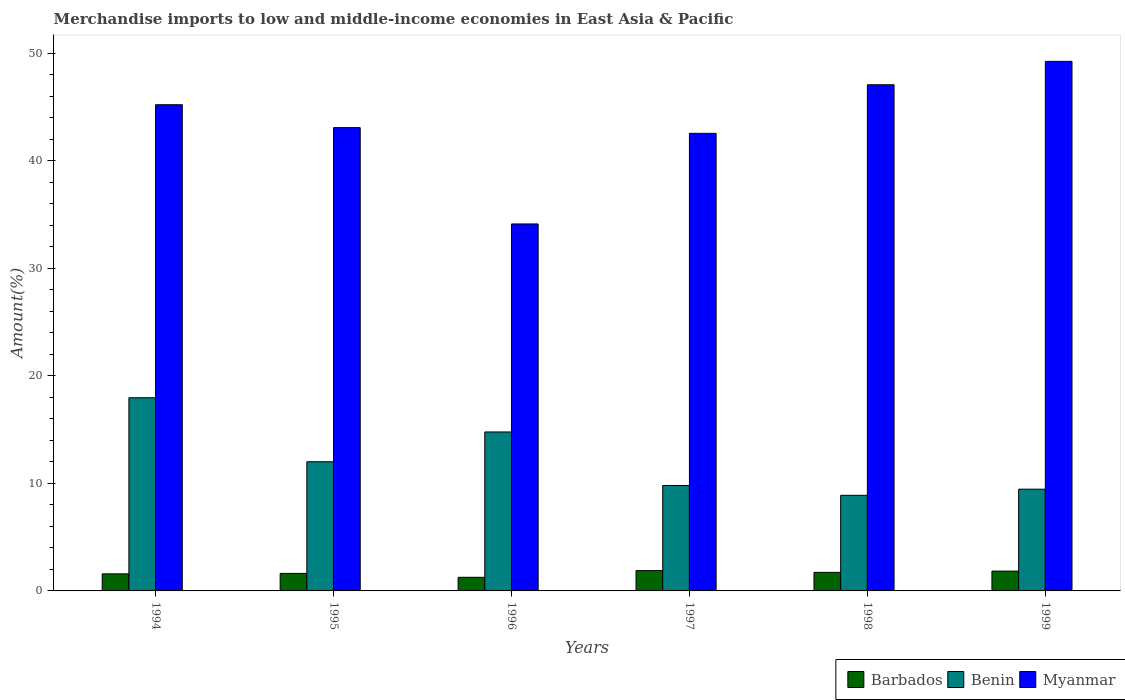How many different coloured bars are there?
Give a very brief answer. 3. Are the number of bars per tick equal to the number of legend labels?
Give a very brief answer. Yes. Are the number of bars on each tick of the X-axis equal?
Give a very brief answer. Yes. How many bars are there on the 4th tick from the left?
Provide a succinct answer. 3. How many bars are there on the 2nd tick from the right?
Offer a terse response. 3. What is the label of the 1st group of bars from the left?
Offer a very short reply. 1994. What is the percentage of amount earned from merchandise imports in Myanmar in 1999?
Your answer should be very brief. 49.23. Across all years, what is the maximum percentage of amount earned from merchandise imports in Myanmar?
Your response must be concise. 49.23. Across all years, what is the minimum percentage of amount earned from merchandise imports in Barbados?
Make the answer very short. 1.27. In which year was the percentage of amount earned from merchandise imports in Benin maximum?
Provide a succinct answer. 1994. In which year was the percentage of amount earned from merchandise imports in Myanmar minimum?
Your answer should be very brief. 1996. What is the total percentage of amount earned from merchandise imports in Myanmar in the graph?
Give a very brief answer. 261.21. What is the difference between the percentage of amount earned from merchandise imports in Barbados in 1996 and that in 1997?
Offer a terse response. -0.63. What is the difference between the percentage of amount earned from merchandise imports in Myanmar in 1998 and the percentage of amount earned from merchandise imports in Benin in 1994?
Provide a short and direct response. 29.1. What is the average percentage of amount earned from merchandise imports in Benin per year?
Your answer should be very brief. 12.15. In the year 1997, what is the difference between the percentage of amount earned from merchandise imports in Barbados and percentage of amount earned from merchandise imports in Benin?
Offer a terse response. -7.91. In how many years, is the percentage of amount earned from merchandise imports in Benin greater than 20 %?
Your answer should be very brief. 0. What is the ratio of the percentage of amount earned from merchandise imports in Benin in 1994 to that in 1996?
Offer a terse response. 1.22. Is the percentage of amount earned from merchandise imports in Myanmar in 1995 less than that in 1998?
Ensure brevity in your answer.  Yes. Is the difference between the percentage of amount earned from merchandise imports in Barbados in 1994 and 1995 greater than the difference between the percentage of amount earned from merchandise imports in Benin in 1994 and 1995?
Your response must be concise. No. What is the difference between the highest and the second highest percentage of amount earned from merchandise imports in Benin?
Make the answer very short. 3.18. What is the difference between the highest and the lowest percentage of amount earned from merchandise imports in Barbados?
Make the answer very short. 0.63. What does the 1st bar from the left in 1997 represents?
Provide a succinct answer. Barbados. What does the 2nd bar from the right in 1995 represents?
Ensure brevity in your answer.  Benin. Are all the bars in the graph horizontal?
Your answer should be very brief. No. How many years are there in the graph?
Your response must be concise. 6. Are the values on the major ticks of Y-axis written in scientific E-notation?
Ensure brevity in your answer.  No. Does the graph contain grids?
Ensure brevity in your answer.  No. How are the legend labels stacked?
Provide a short and direct response. Horizontal. What is the title of the graph?
Keep it short and to the point. Merchandise imports to low and middle-income economies in East Asia & Pacific. Does "Brazil" appear as one of the legend labels in the graph?
Offer a terse response. No. What is the label or title of the Y-axis?
Offer a very short reply. Amount(%). What is the Amount(%) in Barbados in 1994?
Your answer should be very brief. 1.58. What is the Amount(%) in Benin in 1994?
Offer a terse response. 17.96. What is the Amount(%) of Myanmar in 1994?
Give a very brief answer. 45.2. What is the Amount(%) in Barbados in 1995?
Your response must be concise. 1.63. What is the Amount(%) in Benin in 1995?
Offer a terse response. 12.01. What is the Amount(%) of Myanmar in 1995?
Make the answer very short. 43.07. What is the Amount(%) of Barbados in 1996?
Keep it short and to the point. 1.27. What is the Amount(%) in Benin in 1996?
Your response must be concise. 14.78. What is the Amount(%) of Myanmar in 1996?
Your answer should be very brief. 34.12. What is the Amount(%) of Barbados in 1997?
Your response must be concise. 1.89. What is the Amount(%) in Benin in 1997?
Ensure brevity in your answer.  9.8. What is the Amount(%) of Myanmar in 1997?
Keep it short and to the point. 42.54. What is the Amount(%) of Barbados in 1998?
Offer a very short reply. 1.72. What is the Amount(%) in Benin in 1998?
Provide a short and direct response. 8.89. What is the Amount(%) of Myanmar in 1998?
Offer a very short reply. 47.05. What is the Amount(%) of Barbados in 1999?
Provide a succinct answer. 1.84. What is the Amount(%) of Benin in 1999?
Ensure brevity in your answer.  9.46. What is the Amount(%) of Myanmar in 1999?
Ensure brevity in your answer.  49.23. Across all years, what is the maximum Amount(%) of Barbados?
Make the answer very short. 1.89. Across all years, what is the maximum Amount(%) in Benin?
Your answer should be compact. 17.96. Across all years, what is the maximum Amount(%) in Myanmar?
Give a very brief answer. 49.23. Across all years, what is the minimum Amount(%) of Barbados?
Your response must be concise. 1.27. Across all years, what is the minimum Amount(%) in Benin?
Offer a terse response. 8.89. Across all years, what is the minimum Amount(%) of Myanmar?
Ensure brevity in your answer.  34.12. What is the total Amount(%) of Barbados in the graph?
Your answer should be compact. 9.94. What is the total Amount(%) in Benin in the graph?
Ensure brevity in your answer.  72.89. What is the total Amount(%) of Myanmar in the graph?
Provide a succinct answer. 261.21. What is the difference between the Amount(%) in Barbados in 1994 and that in 1995?
Ensure brevity in your answer.  -0.04. What is the difference between the Amount(%) of Benin in 1994 and that in 1995?
Offer a terse response. 5.95. What is the difference between the Amount(%) of Myanmar in 1994 and that in 1995?
Your response must be concise. 2.13. What is the difference between the Amount(%) of Barbados in 1994 and that in 1996?
Keep it short and to the point. 0.32. What is the difference between the Amount(%) in Benin in 1994 and that in 1996?
Provide a short and direct response. 3.18. What is the difference between the Amount(%) of Myanmar in 1994 and that in 1996?
Offer a very short reply. 11.08. What is the difference between the Amount(%) in Barbados in 1994 and that in 1997?
Ensure brevity in your answer.  -0.31. What is the difference between the Amount(%) in Benin in 1994 and that in 1997?
Make the answer very short. 8.16. What is the difference between the Amount(%) in Myanmar in 1994 and that in 1997?
Provide a succinct answer. 2.66. What is the difference between the Amount(%) in Barbados in 1994 and that in 1998?
Your response must be concise. -0.14. What is the difference between the Amount(%) of Benin in 1994 and that in 1998?
Your answer should be compact. 9.07. What is the difference between the Amount(%) in Myanmar in 1994 and that in 1998?
Your answer should be very brief. -1.86. What is the difference between the Amount(%) in Barbados in 1994 and that in 1999?
Offer a terse response. -0.26. What is the difference between the Amount(%) of Benin in 1994 and that in 1999?
Give a very brief answer. 8.5. What is the difference between the Amount(%) of Myanmar in 1994 and that in 1999?
Your answer should be very brief. -4.03. What is the difference between the Amount(%) of Barbados in 1995 and that in 1996?
Offer a very short reply. 0.36. What is the difference between the Amount(%) of Benin in 1995 and that in 1996?
Your answer should be very brief. -2.77. What is the difference between the Amount(%) in Myanmar in 1995 and that in 1996?
Provide a short and direct response. 8.96. What is the difference between the Amount(%) in Barbados in 1995 and that in 1997?
Your answer should be very brief. -0.26. What is the difference between the Amount(%) in Benin in 1995 and that in 1997?
Offer a terse response. 2.21. What is the difference between the Amount(%) of Myanmar in 1995 and that in 1997?
Your answer should be compact. 0.53. What is the difference between the Amount(%) in Barbados in 1995 and that in 1998?
Ensure brevity in your answer.  -0.1. What is the difference between the Amount(%) of Benin in 1995 and that in 1998?
Your answer should be very brief. 3.12. What is the difference between the Amount(%) of Myanmar in 1995 and that in 1998?
Your response must be concise. -3.98. What is the difference between the Amount(%) in Barbados in 1995 and that in 1999?
Offer a terse response. -0.22. What is the difference between the Amount(%) in Benin in 1995 and that in 1999?
Make the answer very short. 2.55. What is the difference between the Amount(%) of Myanmar in 1995 and that in 1999?
Make the answer very short. -6.16. What is the difference between the Amount(%) of Barbados in 1996 and that in 1997?
Your answer should be very brief. -0.63. What is the difference between the Amount(%) in Benin in 1996 and that in 1997?
Give a very brief answer. 4.97. What is the difference between the Amount(%) in Myanmar in 1996 and that in 1997?
Your answer should be very brief. -8.42. What is the difference between the Amount(%) in Barbados in 1996 and that in 1998?
Make the answer very short. -0.46. What is the difference between the Amount(%) of Benin in 1996 and that in 1998?
Your answer should be compact. 5.89. What is the difference between the Amount(%) of Myanmar in 1996 and that in 1998?
Offer a terse response. -12.94. What is the difference between the Amount(%) of Barbados in 1996 and that in 1999?
Make the answer very short. -0.58. What is the difference between the Amount(%) in Benin in 1996 and that in 1999?
Your answer should be compact. 5.32. What is the difference between the Amount(%) of Myanmar in 1996 and that in 1999?
Give a very brief answer. -15.11. What is the difference between the Amount(%) in Barbados in 1997 and that in 1998?
Offer a very short reply. 0.17. What is the difference between the Amount(%) in Benin in 1997 and that in 1998?
Offer a very short reply. 0.91. What is the difference between the Amount(%) of Myanmar in 1997 and that in 1998?
Your answer should be very brief. -4.51. What is the difference between the Amount(%) in Barbados in 1997 and that in 1999?
Make the answer very short. 0.05. What is the difference between the Amount(%) of Benin in 1997 and that in 1999?
Provide a succinct answer. 0.34. What is the difference between the Amount(%) of Myanmar in 1997 and that in 1999?
Ensure brevity in your answer.  -6.69. What is the difference between the Amount(%) of Barbados in 1998 and that in 1999?
Your answer should be very brief. -0.12. What is the difference between the Amount(%) of Benin in 1998 and that in 1999?
Offer a very short reply. -0.57. What is the difference between the Amount(%) in Myanmar in 1998 and that in 1999?
Offer a terse response. -2.18. What is the difference between the Amount(%) in Barbados in 1994 and the Amount(%) in Benin in 1995?
Give a very brief answer. -10.42. What is the difference between the Amount(%) in Barbados in 1994 and the Amount(%) in Myanmar in 1995?
Keep it short and to the point. -41.49. What is the difference between the Amount(%) in Benin in 1994 and the Amount(%) in Myanmar in 1995?
Your answer should be compact. -25.11. What is the difference between the Amount(%) in Barbados in 1994 and the Amount(%) in Benin in 1996?
Ensure brevity in your answer.  -13.19. What is the difference between the Amount(%) of Barbados in 1994 and the Amount(%) of Myanmar in 1996?
Provide a succinct answer. -32.53. What is the difference between the Amount(%) of Benin in 1994 and the Amount(%) of Myanmar in 1996?
Keep it short and to the point. -16.16. What is the difference between the Amount(%) in Barbados in 1994 and the Amount(%) in Benin in 1997?
Offer a terse response. -8.22. What is the difference between the Amount(%) of Barbados in 1994 and the Amount(%) of Myanmar in 1997?
Give a very brief answer. -40.95. What is the difference between the Amount(%) in Benin in 1994 and the Amount(%) in Myanmar in 1997?
Offer a very short reply. -24.58. What is the difference between the Amount(%) of Barbados in 1994 and the Amount(%) of Benin in 1998?
Give a very brief answer. -7.3. What is the difference between the Amount(%) of Barbados in 1994 and the Amount(%) of Myanmar in 1998?
Offer a very short reply. -45.47. What is the difference between the Amount(%) of Benin in 1994 and the Amount(%) of Myanmar in 1998?
Keep it short and to the point. -29.1. What is the difference between the Amount(%) of Barbados in 1994 and the Amount(%) of Benin in 1999?
Ensure brevity in your answer.  -7.87. What is the difference between the Amount(%) in Barbados in 1994 and the Amount(%) in Myanmar in 1999?
Keep it short and to the point. -47.65. What is the difference between the Amount(%) of Benin in 1994 and the Amount(%) of Myanmar in 1999?
Ensure brevity in your answer.  -31.27. What is the difference between the Amount(%) in Barbados in 1995 and the Amount(%) in Benin in 1996?
Provide a short and direct response. -13.15. What is the difference between the Amount(%) in Barbados in 1995 and the Amount(%) in Myanmar in 1996?
Keep it short and to the point. -32.49. What is the difference between the Amount(%) of Benin in 1995 and the Amount(%) of Myanmar in 1996?
Make the answer very short. -22.11. What is the difference between the Amount(%) of Barbados in 1995 and the Amount(%) of Benin in 1997?
Offer a terse response. -8.17. What is the difference between the Amount(%) in Barbados in 1995 and the Amount(%) in Myanmar in 1997?
Give a very brief answer. -40.91. What is the difference between the Amount(%) of Benin in 1995 and the Amount(%) of Myanmar in 1997?
Provide a succinct answer. -30.53. What is the difference between the Amount(%) in Barbados in 1995 and the Amount(%) in Benin in 1998?
Your response must be concise. -7.26. What is the difference between the Amount(%) in Barbados in 1995 and the Amount(%) in Myanmar in 1998?
Your answer should be compact. -45.43. What is the difference between the Amount(%) in Benin in 1995 and the Amount(%) in Myanmar in 1998?
Your answer should be very brief. -35.04. What is the difference between the Amount(%) of Barbados in 1995 and the Amount(%) of Benin in 1999?
Offer a very short reply. -7.83. What is the difference between the Amount(%) in Barbados in 1995 and the Amount(%) in Myanmar in 1999?
Offer a terse response. -47.6. What is the difference between the Amount(%) of Benin in 1995 and the Amount(%) of Myanmar in 1999?
Your answer should be very brief. -37.22. What is the difference between the Amount(%) in Barbados in 1996 and the Amount(%) in Benin in 1997?
Provide a succinct answer. -8.54. What is the difference between the Amount(%) of Barbados in 1996 and the Amount(%) of Myanmar in 1997?
Provide a short and direct response. -41.27. What is the difference between the Amount(%) in Benin in 1996 and the Amount(%) in Myanmar in 1997?
Provide a succinct answer. -27.76. What is the difference between the Amount(%) in Barbados in 1996 and the Amount(%) in Benin in 1998?
Provide a succinct answer. -7.62. What is the difference between the Amount(%) in Barbados in 1996 and the Amount(%) in Myanmar in 1998?
Keep it short and to the point. -45.79. What is the difference between the Amount(%) of Benin in 1996 and the Amount(%) of Myanmar in 1998?
Provide a succinct answer. -32.28. What is the difference between the Amount(%) in Barbados in 1996 and the Amount(%) in Benin in 1999?
Keep it short and to the point. -8.19. What is the difference between the Amount(%) of Barbados in 1996 and the Amount(%) of Myanmar in 1999?
Offer a very short reply. -47.96. What is the difference between the Amount(%) in Benin in 1996 and the Amount(%) in Myanmar in 1999?
Offer a very short reply. -34.45. What is the difference between the Amount(%) of Barbados in 1997 and the Amount(%) of Benin in 1998?
Give a very brief answer. -7. What is the difference between the Amount(%) in Barbados in 1997 and the Amount(%) in Myanmar in 1998?
Offer a terse response. -45.16. What is the difference between the Amount(%) of Benin in 1997 and the Amount(%) of Myanmar in 1998?
Provide a succinct answer. -37.25. What is the difference between the Amount(%) of Barbados in 1997 and the Amount(%) of Benin in 1999?
Ensure brevity in your answer.  -7.57. What is the difference between the Amount(%) in Barbados in 1997 and the Amount(%) in Myanmar in 1999?
Ensure brevity in your answer.  -47.34. What is the difference between the Amount(%) in Benin in 1997 and the Amount(%) in Myanmar in 1999?
Ensure brevity in your answer.  -39.43. What is the difference between the Amount(%) in Barbados in 1998 and the Amount(%) in Benin in 1999?
Ensure brevity in your answer.  -7.73. What is the difference between the Amount(%) in Barbados in 1998 and the Amount(%) in Myanmar in 1999?
Your response must be concise. -47.51. What is the difference between the Amount(%) of Benin in 1998 and the Amount(%) of Myanmar in 1999?
Provide a succinct answer. -40.34. What is the average Amount(%) of Barbados per year?
Give a very brief answer. 1.66. What is the average Amount(%) in Benin per year?
Offer a terse response. 12.15. What is the average Amount(%) of Myanmar per year?
Provide a short and direct response. 43.53. In the year 1994, what is the difference between the Amount(%) in Barbados and Amount(%) in Benin?
Keep it short and to the point. -16.37. In the year 1994, what is the difference between the Amount(%) of Barbados and Amount(%) of Myanmar?
Make the answer very short. -43.61. In the year 1994, what is the difference between the Amount(%) of Benin and Amount(%) of Myanmar?
Your answer should be very brief. -27.24. In the year 1995, what is the difference between the Amount(%) in Barbados and Amount(%) in Benin?
Your answer should be compact. -10.38. In the year 1995, what is the difference between the Amount(%) in Barbados and Amount(%) in Myanmar?
Provide a short and direct response. -41.44. In the year 1995, what is the difference between the Amount(%) in Benin and Amount(%) in Myanmar?
Provide a short and direct response. -31.06. In the year 1996, what is the difference between the Amount(%) in Barbados and Amount(%) in Benin?
Give a very brief answer. -13.51. In the year 1996, what is the difference between the Amount(%) in Barbados and Amount(%) in Myanmar?
Your response must be concise. -32.85. In the year 1996, what is the difference between the Amount(%) of Benin and Amount(%) of Myanmar?
Make the answer very short. -19.34. In the year 1997, what is the difference between the Amount(%) of Barbados and Amount(%) of Benin?
Your response must be concise. -7.91. In the year 1997, what is the difference between the Amount(%) in Barbados and Amount(%) in Myanmar?
Your answer should be very brief. -40.65. In the year 1997, what is the difference between the Amount(%) in Benin and Amount(%) in Myanmar?
Your answer should be compact. -32.74. In the year 1998, what is the difference between the Amount(%) of Barbados and Amount(%) of Benin?
Your answer should be compact. -7.16. In the year 1998, what is the difference between the Amount(%) of Barbados and Amount(%) of Myanmar?
Give a very brief answer. -45.33. In the year 1998, what is the difference between the Amount(%) in Benin and Amount(%) in Myanmar?
Give a very brief answer. -38.17. In the year 1999, what is the difference between the Amount(%) of Barbados and Amount(%) of Benin?
Provide a short and direct response. -7.61. In the year 1999, what is the difference between the Amount(%) in Barbados and Amount(%) in Myanmar?
Offer a terse response. -47.39. In the year 1999, what is the difference between the Amount(%) in Benin and Amount(%) in Myanmar?
Provide a succinct answer. -39.77. What is the ratio of the Amount(%) of Barbados in 1994 to that in 1995?
Keep it short and to the point. 0.97. What is the ratio of the Amount(%) in Benin in 1994 to that in 1995?
Keep it short and to the point. 1.5. What is the ratio of the Amount(%) of Myanmar in 1994 to that in 1995?
Your answer should be compact. 1.05. What is the ratio of the Amount(%) in Barbados in 1994 to that in 1996?
Give a very brief answer. 1.25. What is the ratio of the Amount(%) in Benin in 1994 to that in 1996?
Your answer should be very brief. 1.22. What is the ratio of the Amount(%) in Myanmar in 1994 to that in 1996?
Offer a very short reply. 1.32. What is the ratio of the Amount(%) of Barbados in 1994 to that in 1997?
Give a very brief answer. 0.84. What is the ratio of the Amount(%) in Benin in 1994 to that in 1997?
Offer a very short reply. 1.83. What is the ratio of the Amount(%) of Barbados in 1994 to that in 1998?
Make the answer very short. 0.92. What is the ratio of the Amount(%) of Benin in 1994 to that in 1998?
Provide a short and direct response. 2.02. What is the ratio of the Amount(%) of Myanmar in 1994 to that in 1998?
Your response must be concise. 0.96. What is the ratio of the Amount(%) of Barbados in 1994 to that in 1999?
Give a very brief answer. 0.86. What is the ratio of the Amount(%) of Benin in 1994 to that in 1999?
Offer a terse response. 1.9. What is the ratio of the Amount(%) in Myanmar in 1994 to that in 1999?
Your response must be concise. 0.92. What is the ratio of the Amount(%) in Barbados in 1995 to that in 1996?
Your answer should be very brief. 1.29. What is the ratio of the Amount(%) of Benin in 1995 to that in 1996?
Your answer should be very brief. 0.81. What is the ratio of the Amount(%) of Myanmar in 1995 to that in 1996?
Provide a succinct answer. 1.26. What is the ratio of the Amount(%) in Barbados in 1995 to that in 1997?
Your answer should be very brief. 0.86. What is the ratio of the Amount(%) in Benin in 1995 to that in 1997?
Your answer should be very brief. 1.23. What is the ratio of the Amount(%) of Myanmar in 1995 to that in 1997?
Offer a very short reply. 1.01. What is the ratio of the Amount(%) in Barbados in 1995 to that in 1998?
Offer a terse response. 0.94. What is the ratio of the Amount(%) in Benin in 1995 to that in 1998?
Provide a short and direct response. 1.35. What is the ratio of the Amount(%) in Myanmar in 1995 to that in 1998?
Ensure brevity in your answer.  0.92. What is the ratio of the Amount(%) in Barbados in 1995 to that in 1999?
Your response must be concise. 0.88. What is the ratio of the Amount(%) in Benin in 1995 to that in 1999?
Your answer should be compact. 1.27. What is the ratio of the Amount(%) of Myanmar in 1995 to that in 1999?
Your answer should be compact. 0.87. What is the ratio of the Amount(%) in Barbados in 1996 to that in 1997?
Provide a succinct answer. 0.67. What is the ratio of the Amount(%) of Benin in 1996 to that in 1997?
Your answer should be very brief. 1.51. What is the ratio of the Amount(%) in Myanmar in 1996 to that in 1997?
Ensure brevity in your answer.  0.8. What is the ratio of the Amount(%) of Barbados in 1996 to that in 1998?
Offer a very short reply. 0.73. What is the ratio of the Amount(%) of Benin in 1996 to that in 1998?
Keep it short and to the point. 1.66. What is the ratio of the Amount(%) of Myanmar in 1996 to that in 1998?
Your response must be concise. 0.72. What is the ratio of the Amount(%) of Barbados in 1996 to that in 1999?
Your response must be concise. 0.69. What is the ratio of the Amount(%) in Benin in 1996 to that in 1999?
Keep it short and to the point. 1.56. What is the ratio of the Amount(%) of Myanmar in 1996 to that in 1999?
Provide a succinct answer. 0.69. What is the ratio of the Amount(%) of Barbados in 1997 to that in 1998?
Offer a very short reply. 1.1. What is the ratio of the Amount(%) of Benin in 1997 to that in 1998?
Keep it short and to the point. 1.1. What is the ratio of the Amount(%) in Myanmar in 1997 to that in 1998?
Offer a very short reply. 0.9. What is the ratio of the Amount(%) of Barbados in 1997 to that in 1999?
Your answer should be compact. 1.03. What is the ratio of the Amount(%) in Benin in 1997 to that in 1999?
Ensure brevity in your answer.  1.04. What is the ratio of the Amount(%) of Myanmar in 1997 to that in 1999?
Provide a succinct answer. 0.86. What is the ratio of the Amount(%) in Barbados in 1998 to that in 1999?
Give a very brief answer. 0.93. What is the ratio of the Amount(%) in Benin in 1998 to that in 1999?
Provide a succinct answer. 0.94. What is the ratio of the Amount(%) in Myanmar in 1998 to that in 1999?
Keep it short and to the point. 0.96. What is the difference between the highest and the second highest Amount(%) in Barbados?
Provide a succinct answer. 0.05. What is the difference between the highest and the second highest Amount(%) of Benin?
Your response must be concise. 3.18. What is the difference between the highest and the second highest Amount(%) of Myanmar?
Offer a terse response. 2.18. What is the difference between the highest and the lowest Amount(%) in Barbados?
Offer a terse response. 0.63. What is the difference between the highest and the lowest Amount(%) of Benin?
Your answer should be compact. 9.07. What is the difference between the highest and the lowest Amount(%) of Myanmar?
Ensure brevity in your answer.  15.11. 